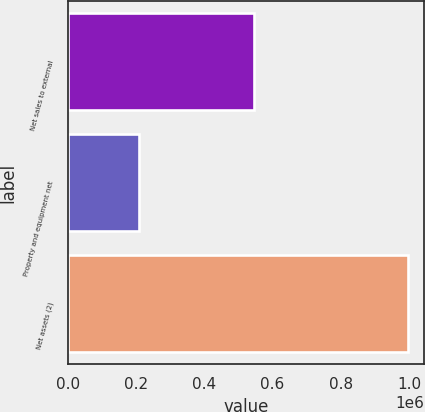Convert chart. <chart><loc_0><loc_0><loc_500><loc_500><bar_chart><fcel>Net sales to external<fcel>Property and equipment net<fcel>Net assets (2)<nl><fcel>545759<fcel>208964<fcel>995272<nl></chart> 